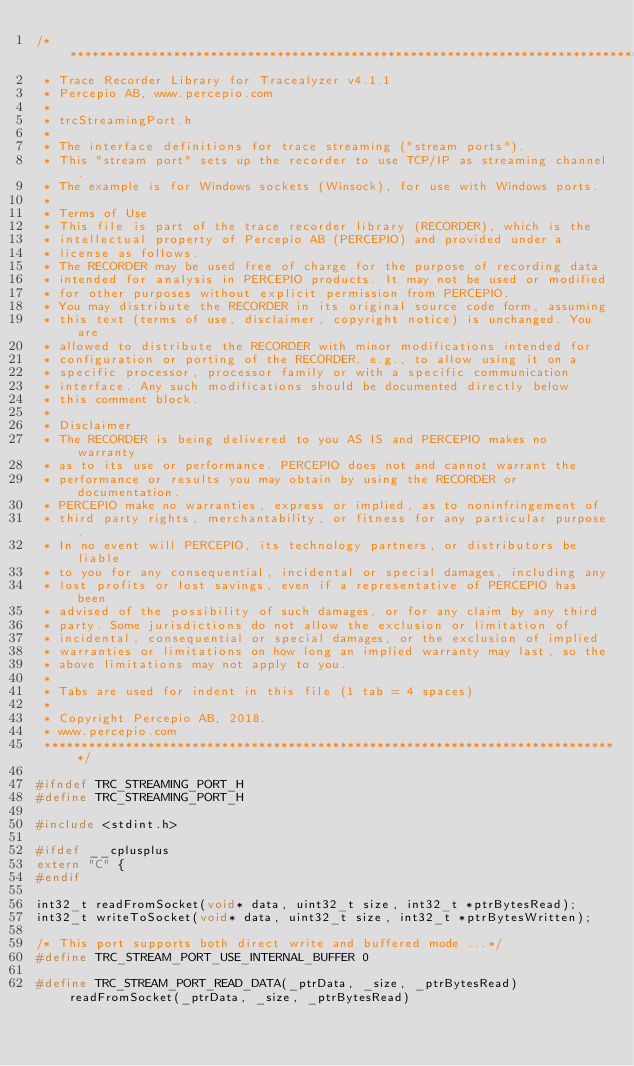<code> <loc_0><loc_0><loc_500><loc_500><_C_>/*******************************************************************************
 * Trace Recorder Library for Tracealyzer v4.1.1
 * Percepio AB, www.percepio.com
 *
 * trcStreamingPort.h
 *
 * The interface definitions for trace streaming ("stream ports").
 * This "stream port" sets up the recorder to use TCP/IP as streaming channel.
 * The example is for Windows sockets (Winsock), for use with Windows ports.
 *
 * Terms of Use
 * This file is part of the trace recorder library (RECORDER), which is the 
 * intellectual property of Percepio AB (PERCEPIO) and provided under a
 * license as follows.
 * The RECORDER may be used free of charge for the purpose of recording data
 * intended for analysis in PERCEPIO products. It may not be used or modified
 * for other purposes without explicit permission from PERCEPIO.
 * You may distribute the RECORDER in its original source code form, assuming
 * this text (terms of use, disclaimer, copyright notice) is unchanged. You are
 * allowed to distribute the RECORDER with minor modifications intended for
 * configuration or porting of the RECORDER, e.g., to allow using it on a 
 * specific processor, processor family or with a specific communication
 * interface. Any such modifications should be documented directly below
 * this comment block.  
 *
 * Disclaimer
 * The RECORDER is being delivered to you AS IS and PERCEPIO makes no warranty
 * as to its use or performance. PERCEPIO does not and cannot warrant the 
 * performance or results you may obtain by using the RECORDER or documentation.
 * PERCEPIO make no warranties, express or implied, as to noninfringement of
 * third party rights, merchantability, or fitness for any particular purpose.
 * In no event will PERCEPIO, its technology partners, or distributors be liable
 * to you for any consequential, incidental or special damages, including any
 * lost profits or lost savings, even if a representative of PERCEPIO has been
 * advised of the possibility of such damages, or for any claim by any third
 * party. Some jurisdictions do not allow the exclusion or limitation of
 * incidental, consequential or special damages, or the exclusion of implied
 * warranties or limitations on how long an implied warranty may last, so the
 * above limitations may not apply to you.
 *
 * Tabs are used for indent in this file (1 tab = 4 spaces)
 *
 * Copyright Percepio AB, 2018.
 * www.percepio.com
 ******************************************************************************/

#ifndef TRC_STREAMING_PORT_H
#define TRC_STREAMING_PORT_H

#include <stdint.h>

#ifdef __cplusplus
extern "C" {
#endif

int32_t readFromSocket(void* data, uint32_t size, int32_t *ptrBytesRead);
int32_t writeToSocket(void* data, uint32_t size, int32_t *ptrBytesWritten);

/* This port supports both direct write and buffered mode ...*/
#define TRC_STREAM_PORT_USE_INTERNAL_BUFFER 0

#define TRC_STREAM_PORT_READ_DATA(_ptrData, _size, _ptrBytesRead) readFromSocket(_ptrData, _size, _ptrBytesRead)
</code> 